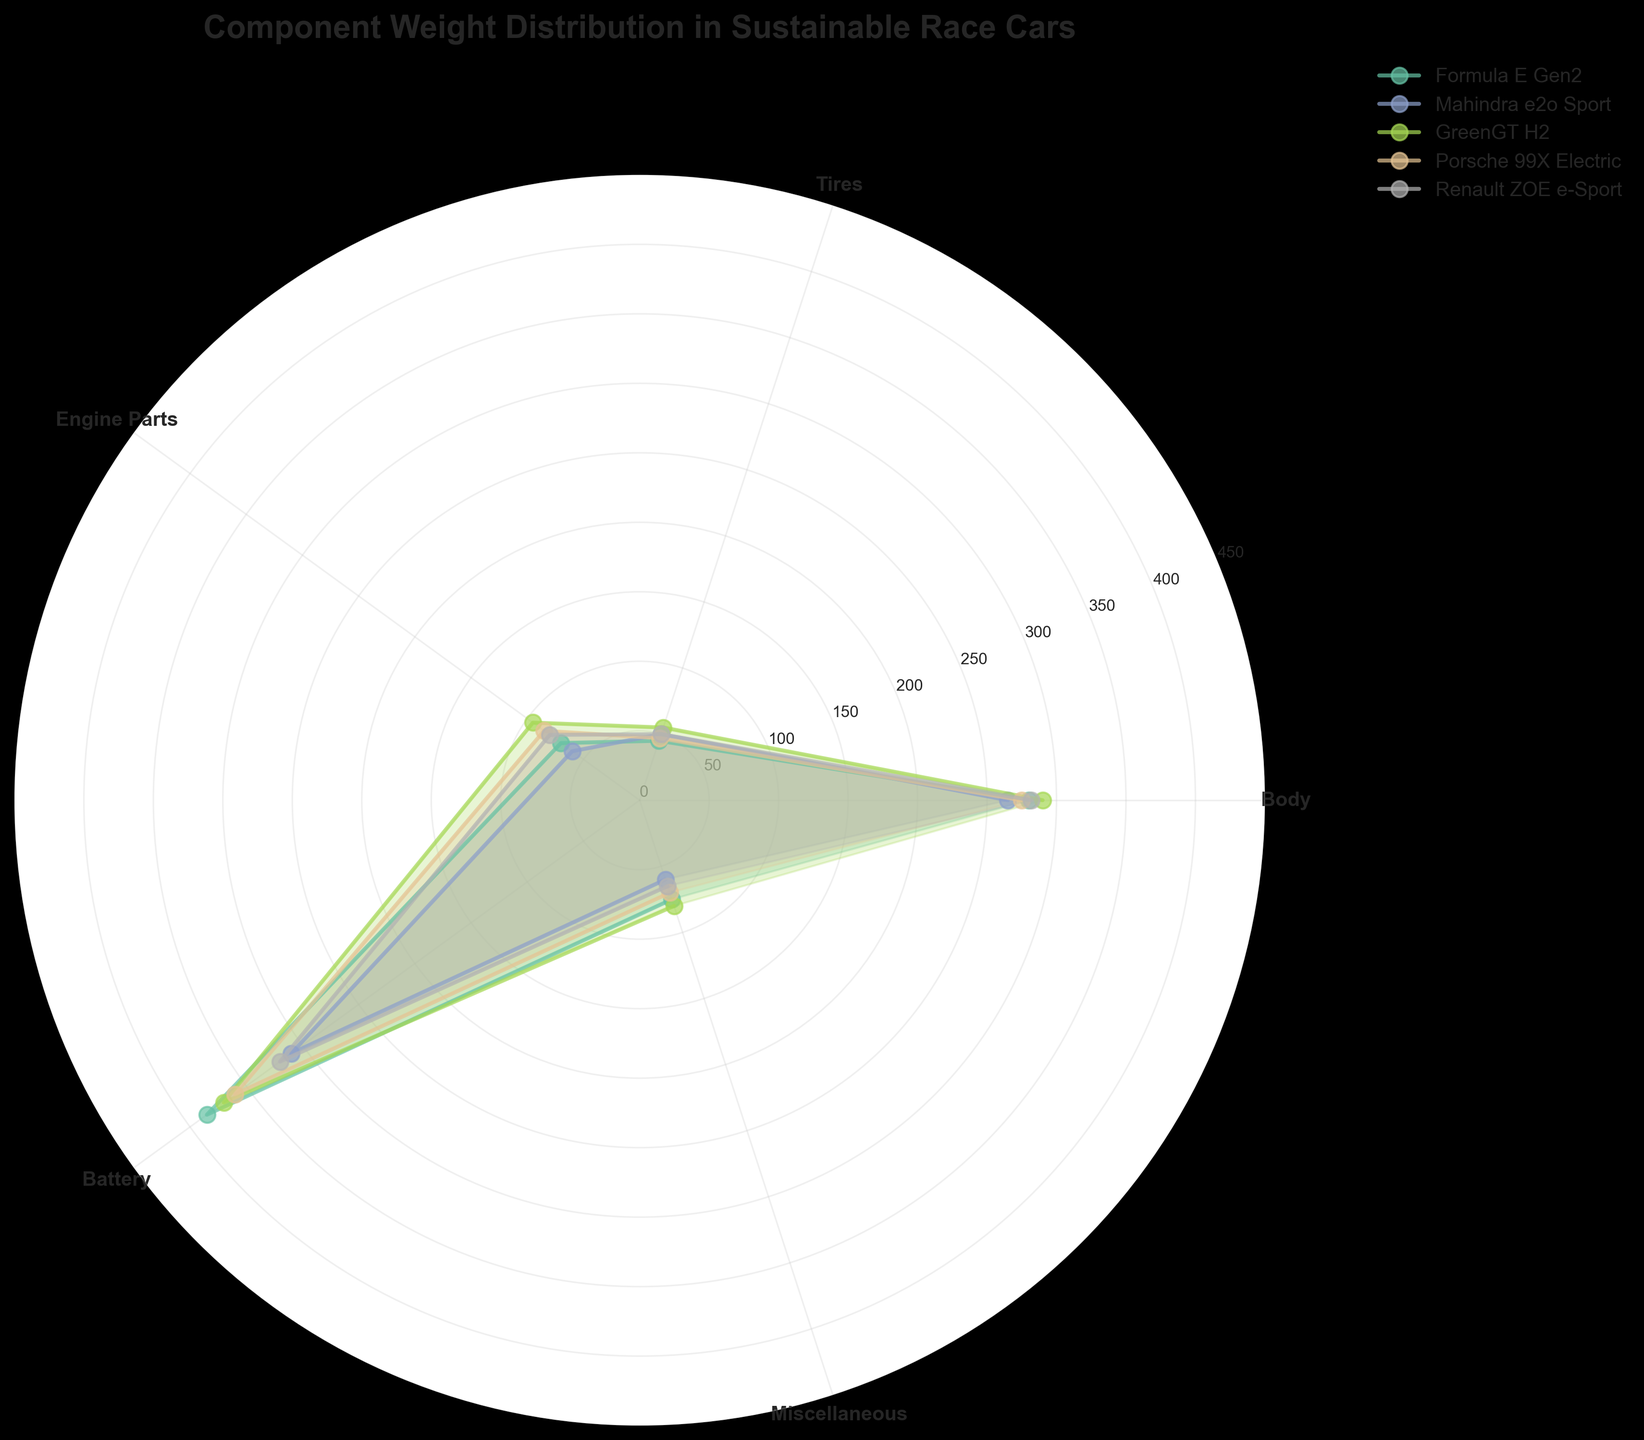What is the title of the chart? The title can be found at the top center of the chart.
Answer: Component Weight Distribution in Sustainable Race Cars Which car model has the heaviest battery? Look at the battery section in each model and compare the values. Formula E Gen2 has the heaviest battery at 385 kg.
Answer: Formula E Gen2 How many unique car models are presented in the chart? Count the number of unique labels in the legend. There are five different car models.
Answer: 5 Which car model has the lightest body? Look at the "Body" section for each car model and identify the one with the smallest value. Mahindra e2o Sport has the lightest body at 265 kg.
Answer: Mahindra e2o Sport What is the average weight of the tires across all car models? Sum the weights of the tires for each car model and then divide by the number of car models. (45 + 50 + 55 + 47 + 50) / 5 = 49.4 kg
Answer: 49.4 kg Which components show the most variation in weight among the different car models? Compare the weight ranges for each component across all models. The "Battery" component has the highest range from 310 kg to 385 kg.
Answer: Battery Compare the weights of engine parts for Formula E Gen2 and GreenGT H2. Which one is heavier? Look at the "Engine Parts" section for both models and compare the values. GreenGT H2 has heavier engine parts at 95 kg compared to Formula E Gen2, which has 70 kg.
Answer: GreenGT H2 How do the miscellaneous component weights of Porsche 99X Electric and Renault ZOE e-Sport compare? Look at the "Miscellaneous" section for both models and compare the values. Porsche 99X Electric has 70 kg, and Renault ZOE e-Sport has 65 kg.
Answer: Porsche 99X Electric > Renault ZOE e-Sport Which car model has the most equal weight distribution among all its components? Visually assess which model's plot appears more balanced across all angles without significant peaks. Mahindra e2o Sport appears the most balanced.
Answer: Mahindra e2o Sport 